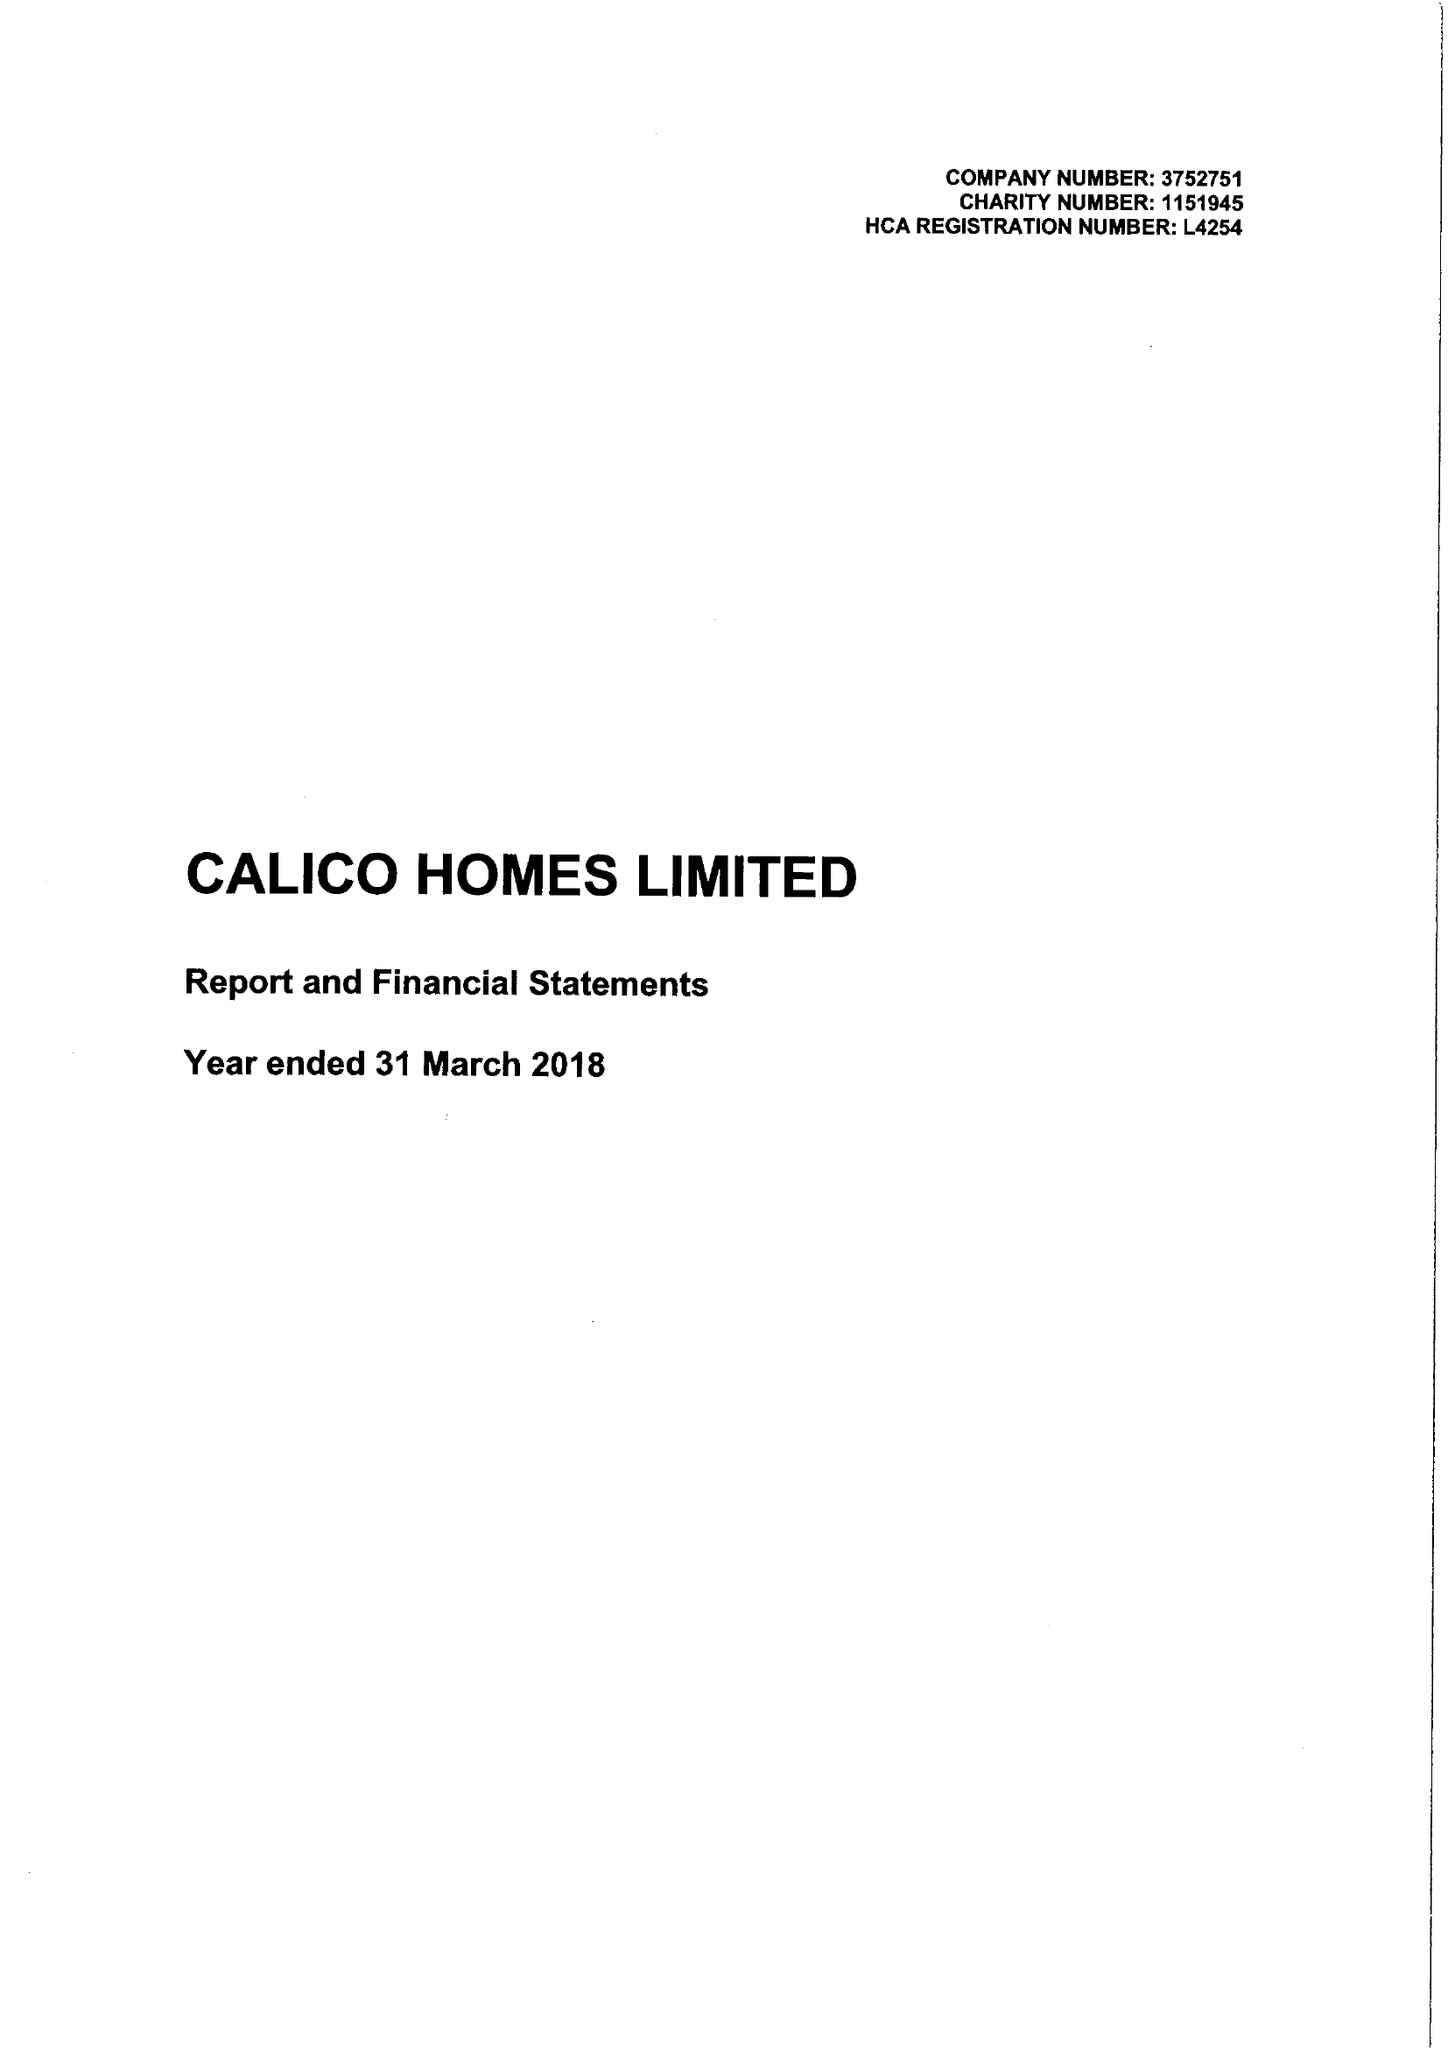What is the value for the address__postcode?
Answer the question using a single word or phrase. BB11 2ED 